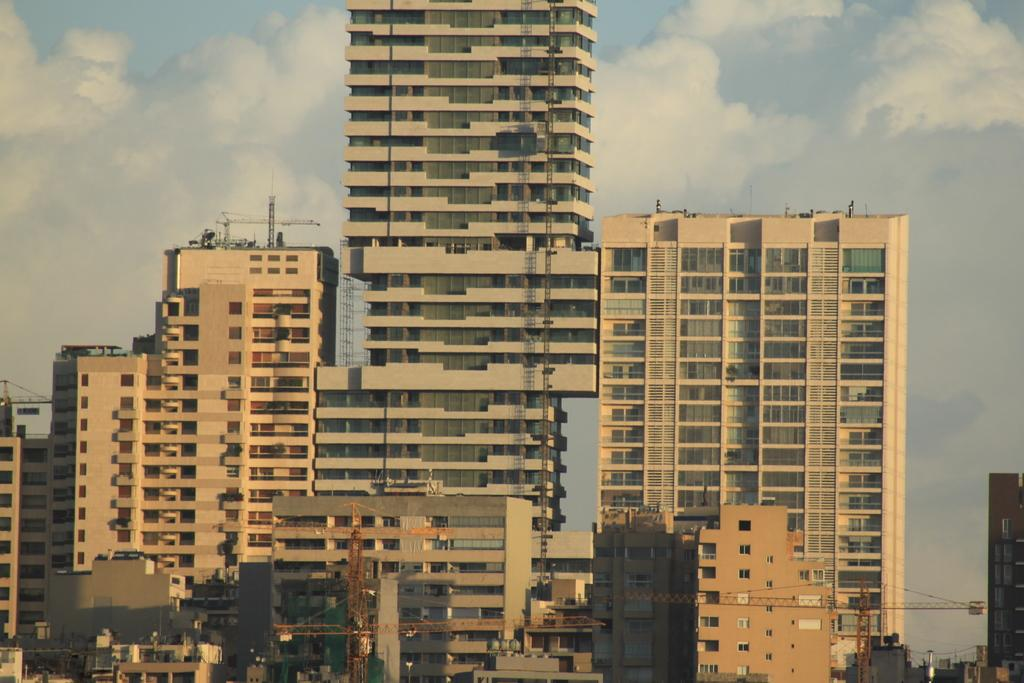What type of buildings can be seen in the image? There are skyscrapers in the image. What part of the natural environment is visible in the image? The sky is visible in the image. What type of clam is being used as a crayon in the image? There is no clam or crayon present in the image; it only features skyscrapers and the sky. 